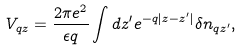<formula> <loc_0><loc_0><loc_500><loc_500>V _ { { q } z } = \frac { 2 \pi e ^ { 2 } } { \epsilon q } \int d z ^ { \prime } e ^ { - q | z - z ^ { \prime } | } \delta n _ { { q } z ^ { \prime } } ,</formula> 